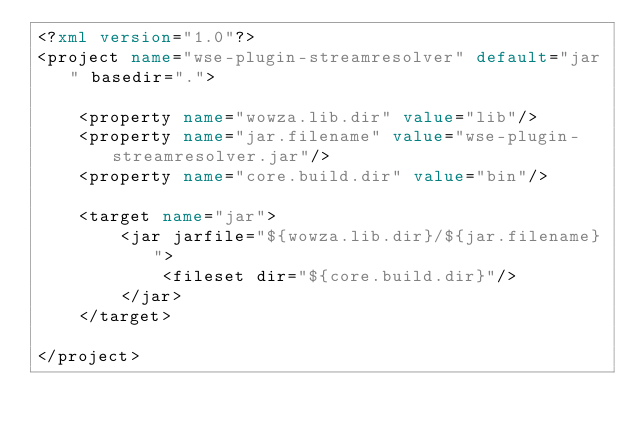<code> <loc_0><loc_0><loc_500><loc_500><_XML_><?xml version="1.0"?>
<project name="wse-plugin-streamresolver" default="jar" basedir=".">
	
	<property name="wowza.lib.dir" value="lib"/>
	<property name="jar.filename" value="wse-plugin-streamresolver.jar"/>
	<property name="core.build.dir" value="bin"/>

	<target name="jar">
		<jar jarfile="${wowza.lib.dir}/${jar.filename}">
			<fileset dir="${core.build.dir}"/>
		</jar>
	</target>
	
</project>
</code> 